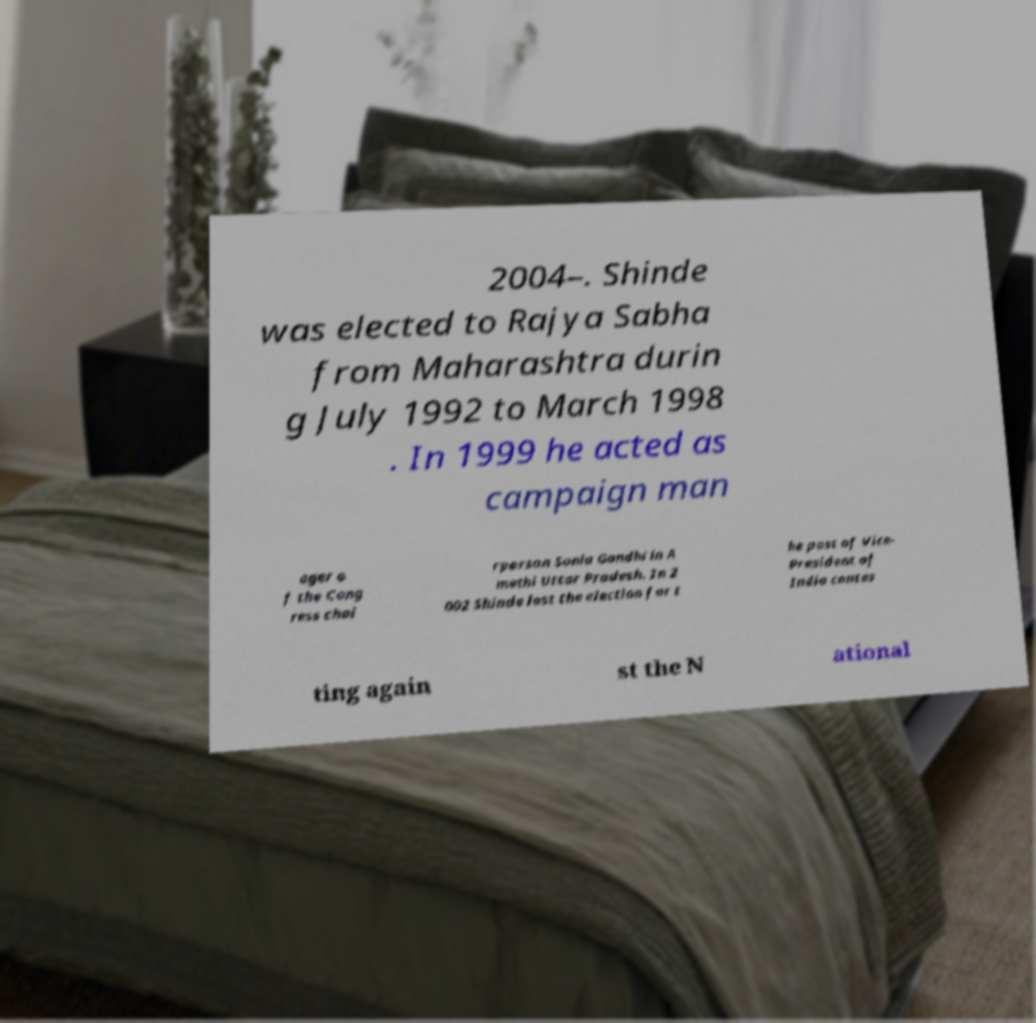Can you read and provide the text displayed in the image?This photo seems to have some interesting text. Can you extract and type it out for me? 2004–. Shinde was elected to Rajya Sabha from Maharashtra durin g July 1992 to March 1998 . In 1999 he acted as campaign man ager o f the Cong ress chai rperson Sonia Gandhi in A methi Uttar Pradesh. In 2 002 Shinde lost the election for t he post of Vice- President of India contes ting again st the N ational 